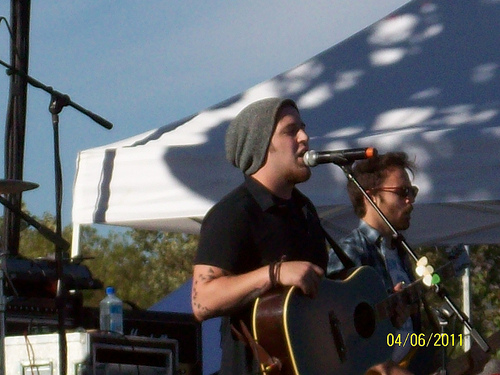<image>
Can you confirm if the guitar is to the right of the man? No. The guitar is not to the right of the man. The horizontal positioning shows a different relationship. 